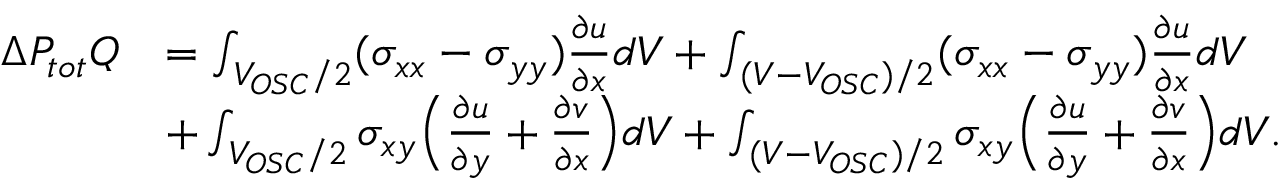Convert formula to latex. <formula><loc_0><loc_0><loc_500><loc_500>\begin{array} { r l } { \Delta P _ { t o t } Q } & { = \int _ { V _ { O S C } / 2 } ( \sigma _ { x x } - \sigma _ { y y } ) \frac { \partial u } { \partial x } d V + \int _ { ( V - V _ { O S C } ) / 2 } ( \sigma _ { x x } - \sigma _ { y y } ) \frac { \partial u } { \partial x } d V } \\ & { + \int _ { V _ { O S C } / 2 } \sigma _ { x y } \left ( \frac { \partial u } { \partial y } + \frac { \partial v } { \partial x } \right ) d V + \int _ { ( V - V _ { O S C } ) / 2 } \sigma _ { x y } \left ( \frac { \partial u } { \partial y } + \frac { \partial v } { \partial x } \right ) d V . } \end{array}</formula> 